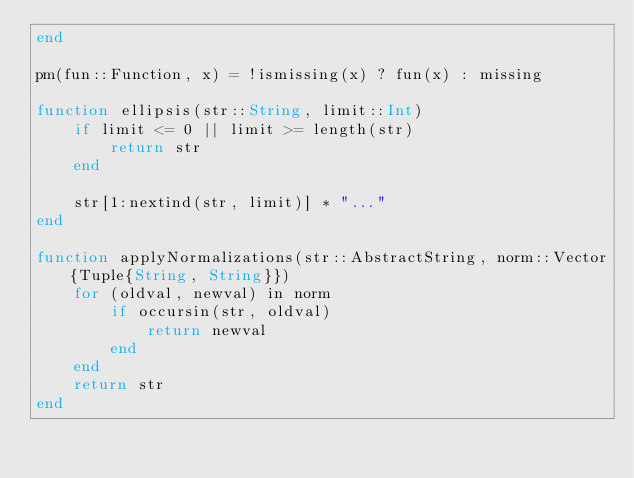Convert code to text. <code><loc_0><loc_0><loc_500><loc_500><_Julia_>end

pm(fun::Function, x) = !ismissing(x) ? fun(x) : missing

function ellipsis(str::String, limit::Int)
	if limit <= 0 || limit >= length(str)
		return str
	end

	str[1:nextind(str, limit)] * "..."
end

function applyNormalizations(str::AbstractString, norm::Vector{Tuple{String, String}})
	for (oldval, newval) in norm
		if occursin(str, oldval)
			return newval
		end
	end
	return str
end
</code> 